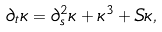<formula> <loc_0><loc_0><loc_500><loc_500>\partial _ { t } \kappa = \partial _ { s } ^ { 2 } \kappa + \kappa ^ { 3 } + S \kappa ,</formula> 